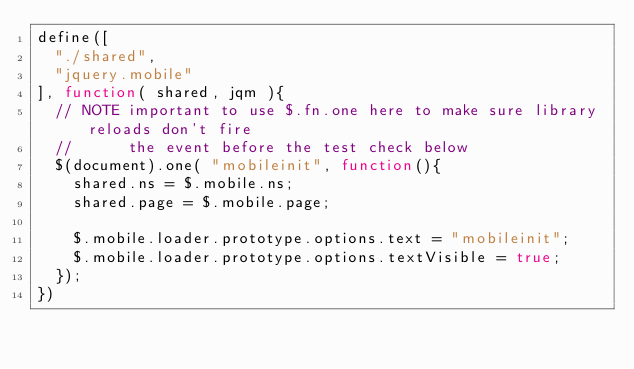Convert code to text. <code><loc_0><loc_0><loc_500><loc_500><_JavaScript_>define([
	"./shared",
	"jquery.mobile"
], function( shared, jqm ){
	// NOTE important to use $.fn.one here to make sure library reloads don't fire
	//      the event before the test check below
	$(document).one( "mobileinit", function(){
		shared.ns = $.mobile.ns;
		shared.page = $.mobile.page;

		$.mobile.loader.prototype.options.text = "mobileinit";
		$.mobile.loader.prototype.options.textVisible = true;
	});
})</code> 